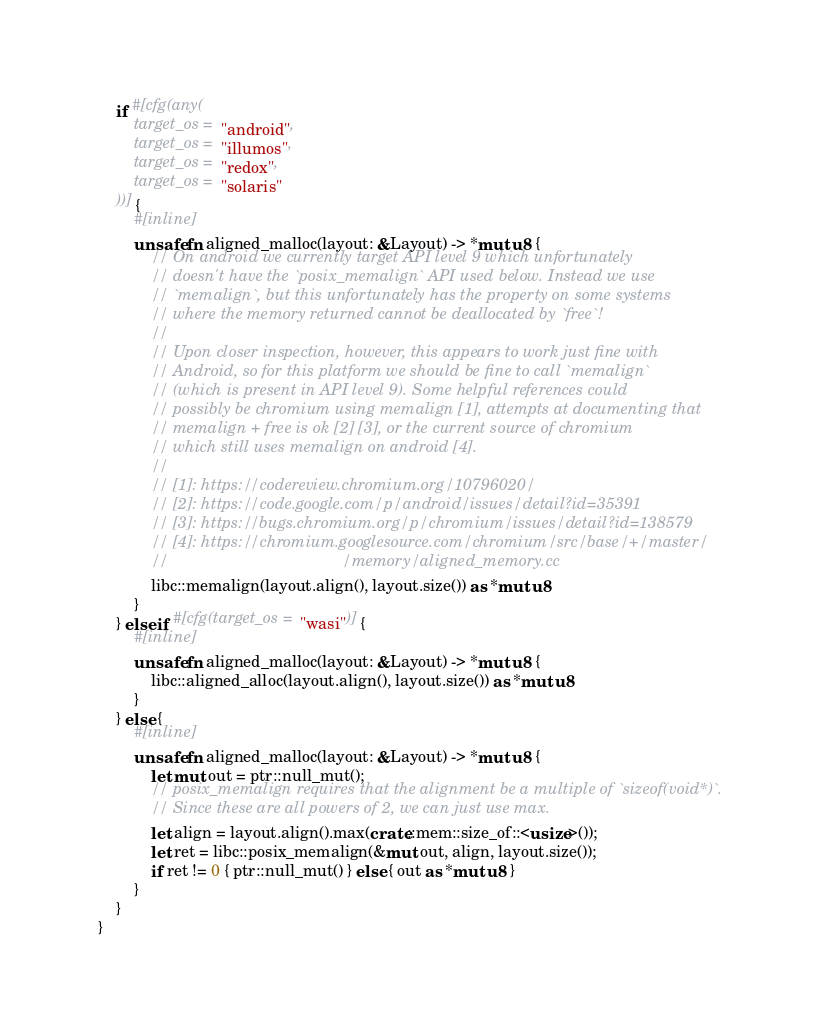<code> <loc_0><loc_0><loc_500><loc_500><_Rust_>    if #[cfg(any(
        target_os = "android",
        target_os = "illumos",
        target_os = "redox",
        target_os = "solaris"
    ))] {
        #[inline]
        unsafe fn aligned_malloc(layout: &Layout) -> *mut u8 {
            // On android we currently target API level 9 which unfortunately
            // doesn't have the `posix_memalign` API used below. Instead we use
            // `memalign`, but this unfortunately has the property on some systems
            // where the memory returned cannot be deallocated by `free`!
            //
            // Upon closer inspection, however, this appears to work just fine with
            // Android, so for this platform we should be fine to call `memalign`
            // (which is present in API level 9). Some helpful references could
            // possibly be chromium using memalign [1], attempts at documenting that
            // memalign + free is ok [2] [3], or the current source of chromium
            // which still uses memalign on android [4].
            //
            // [1]: https://codereview.chromium.org/10796020/
            // [2]: https://code.google.com/p/android/issues/detail?id=35391
            // [3]: https://bugs.chromium.org/p/chromium/issues/detail?id=138579
            // [4]: https://chromium.googlesource.com/chromium/src/base/+/master/
            //                                       /memory/aligned_memory.cc
            libc::memalign(layout.align(), layout.size()) as *mut u8
        }
    } else if #[cfg(target_os = "wasi")] {
        #[inline]
        unsafe fn aligned_malloc(layout: &Layout) -> *mut u8 {
            libc::aligned_alloc(layout.align(), layout.size()) as *mut u8
        }
    } else {
        #[inline]
        unsafe fn aligned_malloc(layout: &Layout) -> *mut u8 {
            let mut out = ptr::null_mut();
            // posix_memalign requires that the alignment be a multiple of `sizeof(void*)`.
            // Since these are all powers of 2, we can just use max.
            let align = layout.align().max(crate::mem::size_of::<usize>());
            let ret = libc::posix_memalign(&mut out, align, layout.size());
            if ret != 0 { ptr::null_mut() } else { out as *mut u8 }
        }
    }
}
</code> 